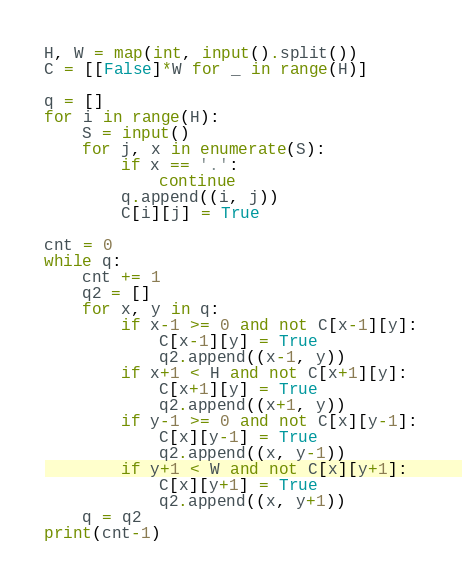Convert code to text. <code><loc_0><loc_0><loc_500><loc_500><_Python_>H, W = map(int, input().split())
C = [[False]*W for _ in range(H)]

q = []
for i in range(H):
    S = input()
    for j, x in enumerate(S):
        if x == '.':
            continue
        q.append((i, j))
        C[i][j] = True

cnt = 0
while q:
    cnt += 1
    q2 = []
    for x, y in q:
        if x-1 >= 0 and not C[x-1][y]:
            C[x-1][y] = True
            q2.append((x-1, y))
        if x+1 < H and not C[x+1][y]:
            C[x+1][y] = True
            q2.append((x+1, y))
        if y-1 >= 0 and not C[x][y-1]:
            C[x][y-1] = True
            q2.append((x, y-1))
        if y+1 < W and not C[x][y+1]:
            C[x][y+1] = True
            q2.append((x, y+1))
    q = q2
print(cnt-1)
</code> 